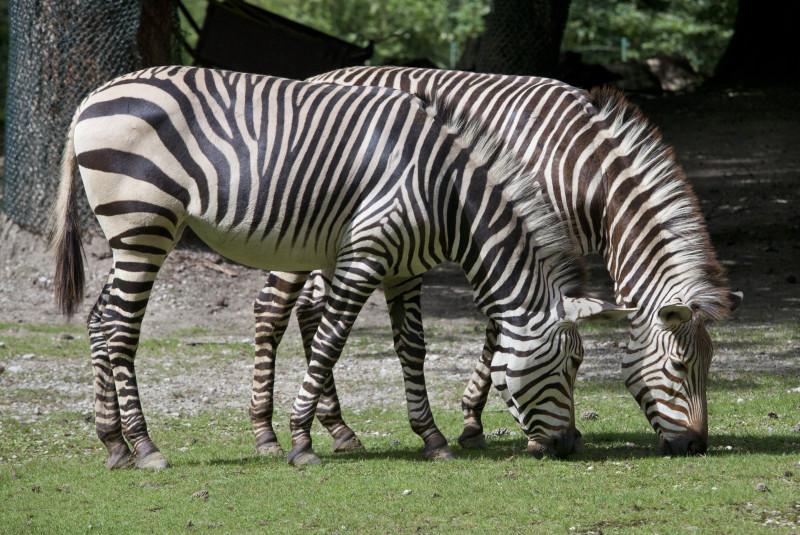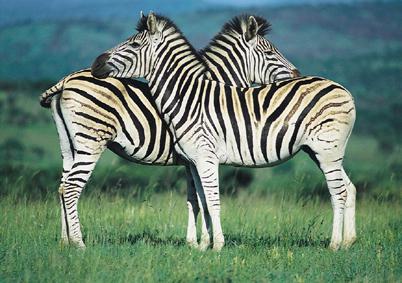The first image is the image on the left, the second image is the image on the right. Evaluate the accuracy of this statement regarding the images: "At least one baby zebra is staying close to its mom.". Is it true? Answer yes or no. No. The first image is the image on the left, the second image is the image on the right. Evaluate the accuracy of this statement regarding the images: "Each image contains two zebras of similar size, and in at least one image, the head of one zebra is over the back of the other zebra.". Is it true? Answer yes or no. Yes. 